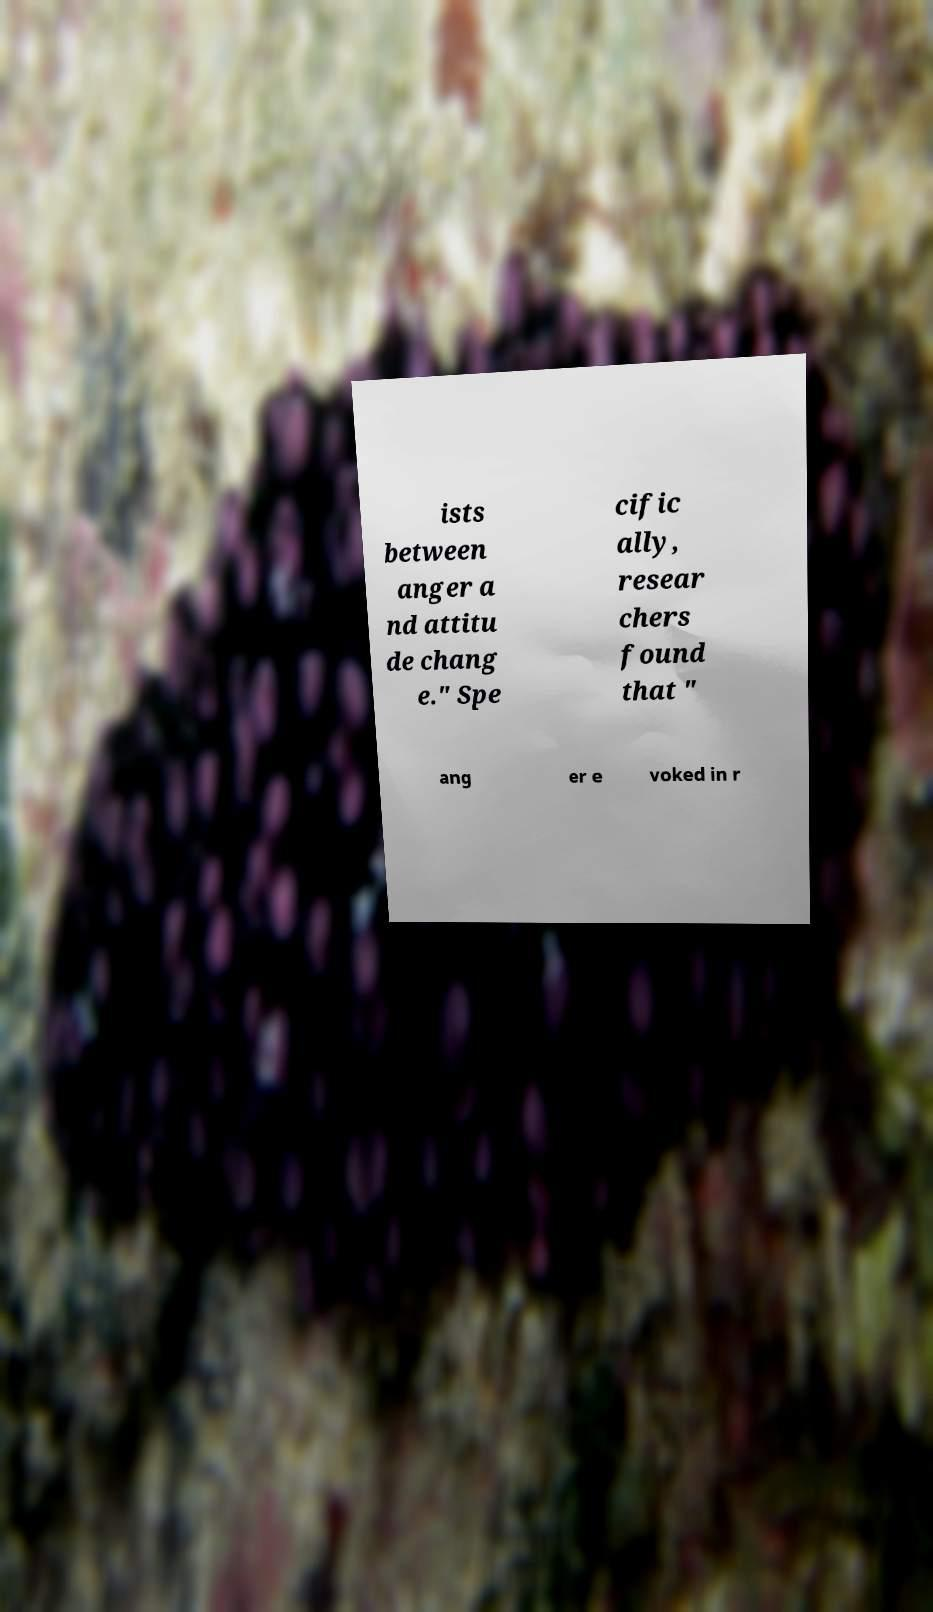Could you extract and type out the text from this image? ists between anger a nd attitu de chang e." Spe cific ally, resear chers found that " ang er e voked in r 